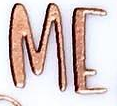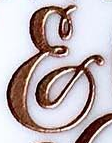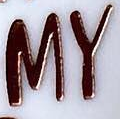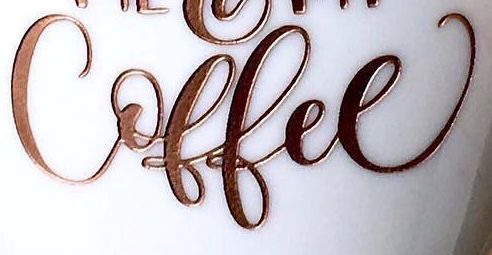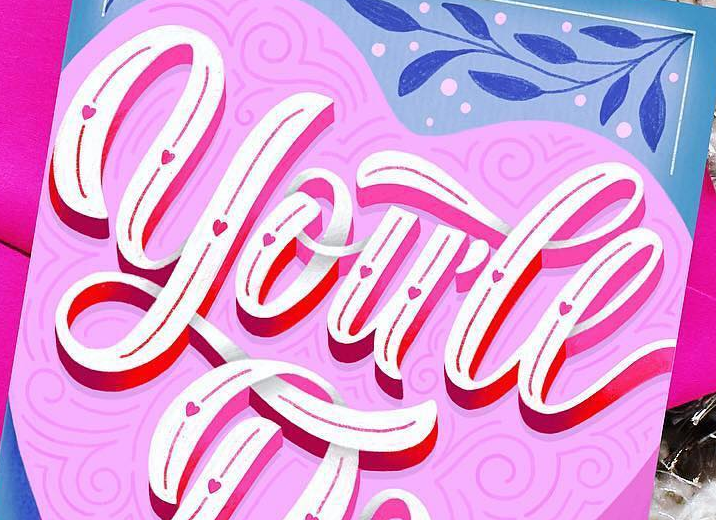Identify the words shown in these images in order, separated by a semicolon. ME; &; MY; Coffee; you'll 